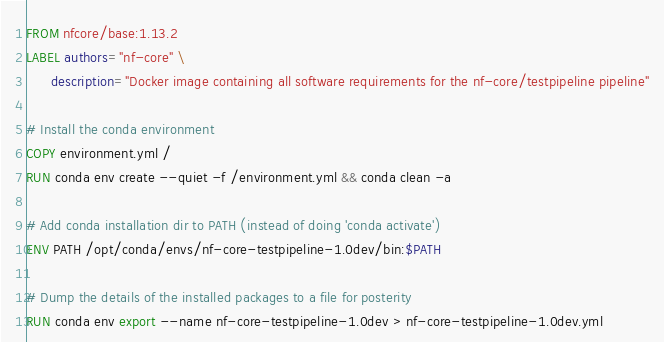<code> <loc_0><loc_0><loc_500><loc_500><_Dockerfile_>FROM nfcore/base:1.13.2
LABEL authors="nf-core" \
      description="Docker image containing all software requirements for the nf-core/testpipeline pipeline"

# Install the conda environment
COPY environment.yml /
RUN conda env create --quiet -f /environment.yml && conda clean -a

# Add conda installation dir to PATH (instead of doing 'conda activate')
ENV PATH /opt/conda/envs/nf-core-testpipeline-1.0dev/bin:$PATH

# Dump the details of the installed packages to a file for posterity
RUN conda env export --name nf-core-testpipeline-1.0dev > nf-core-testpipeline-1.0dev.yml
</code> 